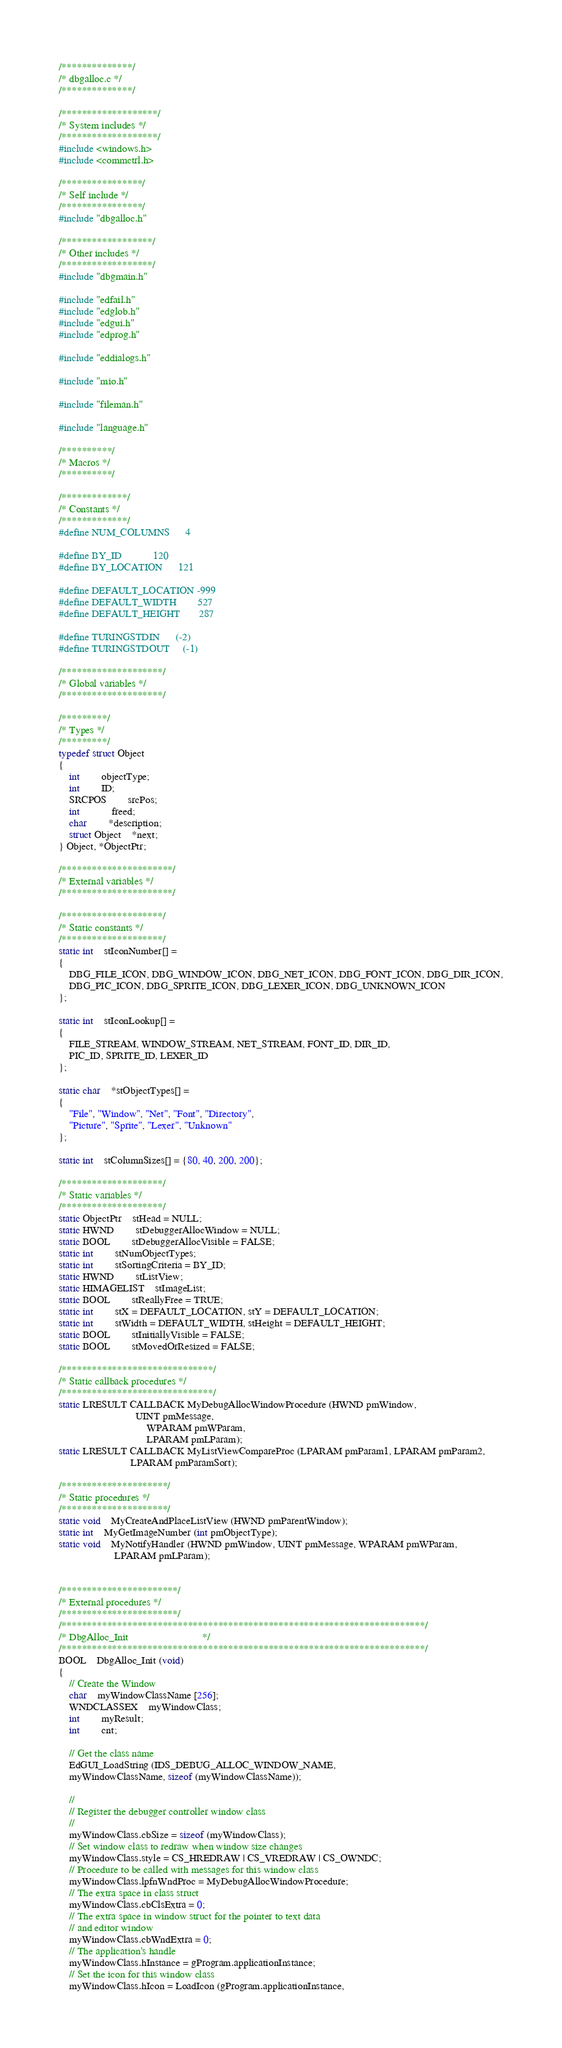Convert code to text. <code><loc_0><loc_0><loc_500><loc_500><_C_>/**************/
/* dbgalloc.c */
/**************/

/*******************/
/* System includes */
/*******************/
#include <windows.h>
#include <commctrl.h>

/****************/
/* Self include */
/****************/
#include "dbgalloc.h"

/******************/
/* Other includes */
/******************/
#include "dbgmain.h"

#include "edfail.h"
#include "edglob.h"
#include "edgui.h"
#include "edprog.h"

#include "eddialogs.h"

#include "mio.h"

#include "fileman.h"

#include "language.h"

/**********/
/* Macros */
/**********/

/*************/
/* Constants */
/*************/
#define NUM_COLUMNS		4

#define BY_ID			120
#define BY_LOCATION		121

#define DEFAULT_LOCATION	-999
#define DEFAULT_WIDTH		527
#define DEFAULT_HEIGHT		287
				
#define TURINGSTDIN		(-2)
#define TURINGSTDOUT		(-1)

/********************/
/* Global variables */
/********************/

/*********/
/* Types */
/*********/
typedef struct Object
{
    int 		objectType;
    int 		ID;
    SRCPOS 		srcPos;
    int			freed;
    char 		*description;
    struct Object	*next;
} Object, *ObjectPtr;

/**********************/
/* External variables */
/**********************/

/********************/
/* Static constants */
/********************/
static int	stIconNumber[] = 
{
    DBG_FILE_ICON, DBG_WINDOW_ICON, DBG_NET_ICON, DBG_FONT_ICON, DBG_DIR_ICON,
    DBG_PIC_ICON, DBG_SPRITE_ICON, DBG_LEXER_ICON, DBG_UNKNOWN_ICON
};

static int	stIconLookup[] = 
{
    FILE_STREAM, WINDOW_STREAM, NET_STREAM, FONT_ID, DIR_ID, 
    PIC_ID, SPRITE_ID, LEXER_ID
};

static char	*stObjectTypes[] = 
{
    "File", "Window", "Net", "Font", "Directory",
    "Picture", "Sprite", "Lexer", "Unknown"
};

static int	stColumnSizes[] = {80, 40, 200, 200};
	
/********************/
/* Static variables */
/********************/
static ObjectPtr	stHead = NULL;
static HWND		stDebuggerAllocWindow = NULL;
static BOOL		stDebuggerAllocVisible = FALSE;
static int		stNumObjectTypes;
static int		stSortingCriteria = BY_ID;
static HWND		stListView;
static HIMAGELIST	stImageList;
static BOOL		stReallyFree = TRUE;
static int		stX = DEFAULT_LOCATION, stY = DEFAULT_LOCATION;
static int		stWidth = DEFAULT_WIDTH, stHeight = DEFAULT_HEIGHT;
static BOOL		stInitiallyVisible = FALSE;
static BOOL		stMovedOrResized = FALSE;

/******************************/
/* Static callback procedures */
/******************************/
static LRESULT CALLBACK MyDebugAllocWindowProcedure (HWND pmWindow, 
						     UINT pmMessage, 
	    					     WPARAM pmWParam, 
	    					     LPARAM pmLParam);
static LRESULT CALLBACK MyListViewCompareProc (LPARAM pmParam1, LPARAM pmParam2,
					       LPARAM pmParamSort);

/*********************/
/* Static procedures */
/*********************/
static void	MyCreateAndPlaceListView (HWND pmParentWindow);
static int	MyGetImageNumber (int pmObjectType);
static void	MyNotifyHandler (HWND pmWindow, UINT pmMessage, WPARAM pmWParam, 
	    			 LPARAM pmLParam);


/***********************/
/* External procedures */
/***********************/
/************************************************************************/
/* DbgAlloc_Init							*/
/************************************************************************/
BOOL	DbgAlloc_Init (void)
{
    // Create the Window
    char	myWindowClassName [256];
    WNDCLASSEX	myWindowClass;
    int		myResult;
    int		cnt;
        
    // Get the class name
    EdGUI_LoadString (IDS_DEBUG_ALLOC_WINDOW_NAME, 
	myWindowClassName, sizeof (myWindowClassName));
    
    //
    // Register the debugger controller window class
    //
    myWindowClass.cbSize = sizeof (myWindowClass);
    // Set window class to redraw when window size changes
    myWindowClass.style = CS_HREDRAW | CS_VREDRAW | CS_OWNDC;
    // Procedure to be called with messages for this window class
    myWindowClass.lpfnWndProc = MyDebugAllocWindowProcedure;
    // The extra space in class struct
    myWindowClass.cbClsExtra = 0;
    // The extra space in window struct for the pointer to text data
    // and editor window
    myWindowClass.cbWndExtra = 0;
    // The application's handle
    myWindowClass.hInstance = gProgram.applicationInstance;
    // Set the icon for this window class
    myWindowClass.hIcon = LoadIcon (gProgram.applicationInstance, </code> 